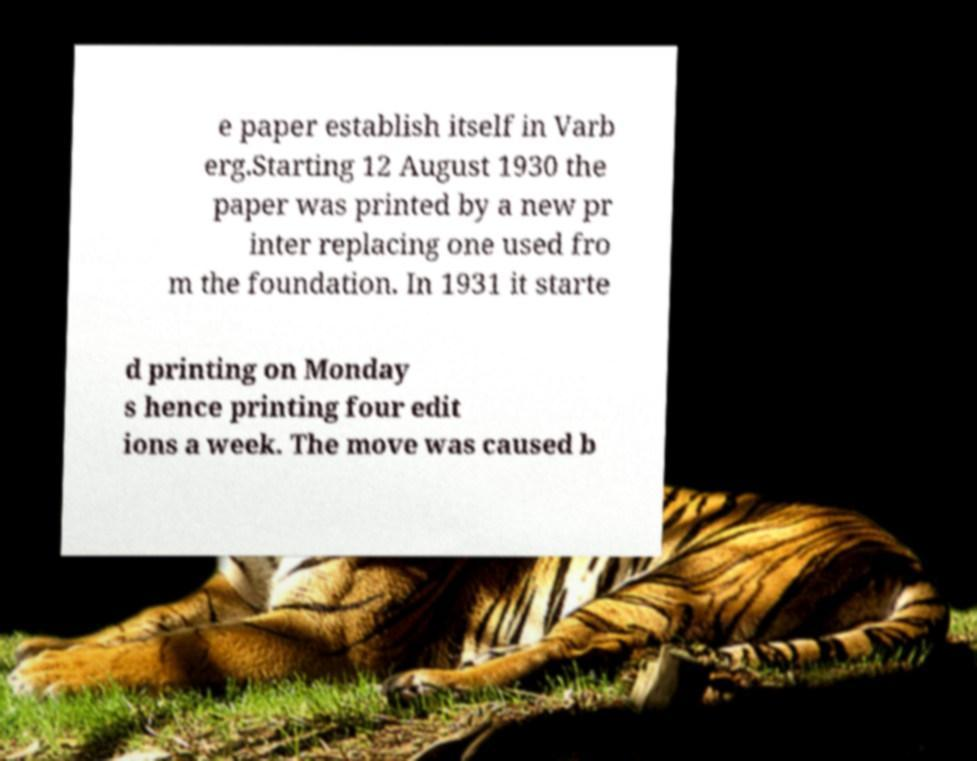There's text embedded in this image that I need extracted. Can you transcribe it verbatim? e paper establish itself in Varb erg.Starting 12 August 1930 the paper was printed by a new pr inter replacing one used fro m the foundation. In 1931 it starte d printing on Monday s hence printing four edit ions a week. The move was caused b 